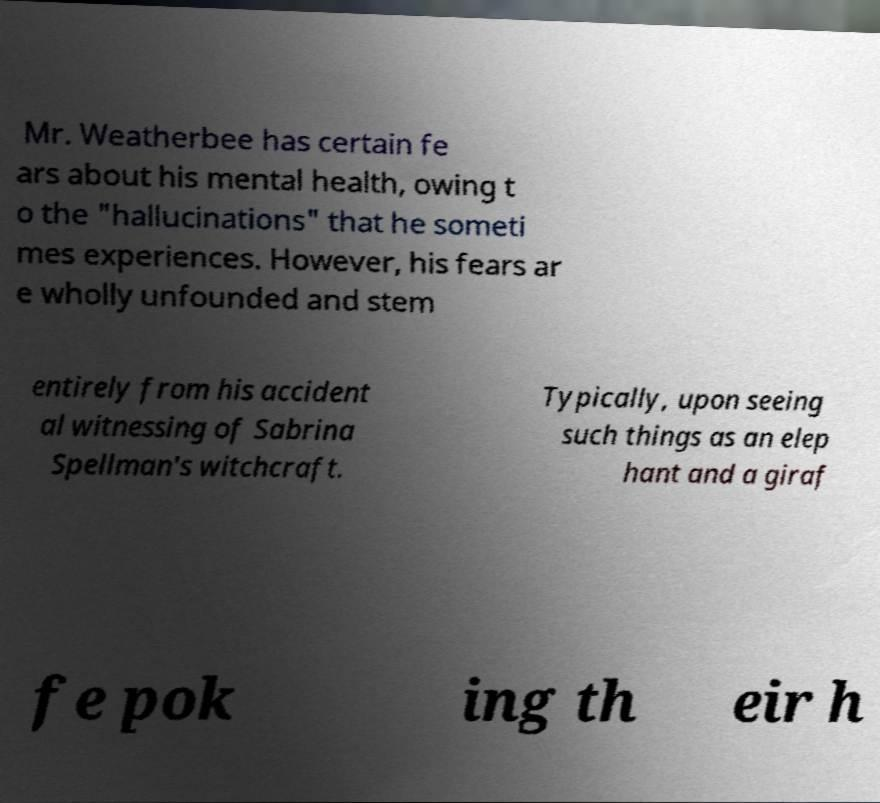Can you accurately transcribe the text from the provided image for me? Mr. Weatherbee has certain fe ars about his mental health, owing t o the "hallucinations" that he someti mes experiences. However, his fears ar e wholly unfounded and stem entirely from his accident al witnessing of Sabrina Spellman's witchcraft. Typically, upon seeing such things as an elep hant and a giraf fe pok ing th eir h 